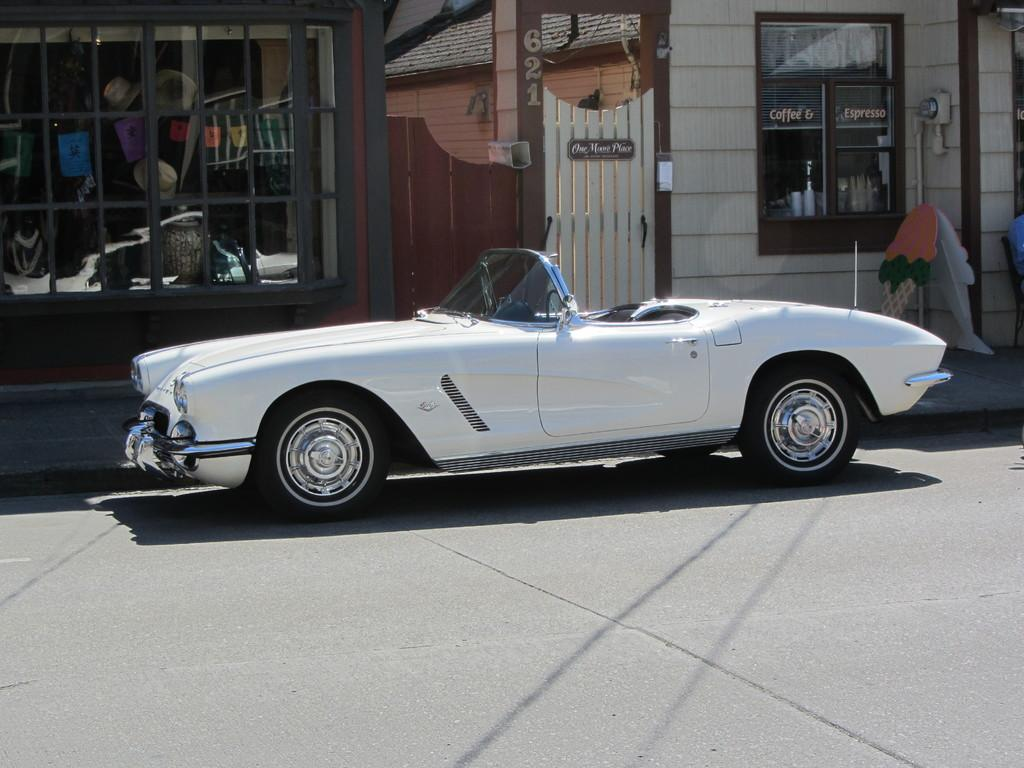What type of structures can be seen in the image? There are houses in the image. What part of a house is visible in the image? There is a window in the image. What type of entrance is present in the image? There is a gate in the image. What type of vehicle can be seen in the image? There is a white color car in the image. What type of honey is being harvested from the car in the image? There is no honey or car-related honey harvesting activity present in the image. 